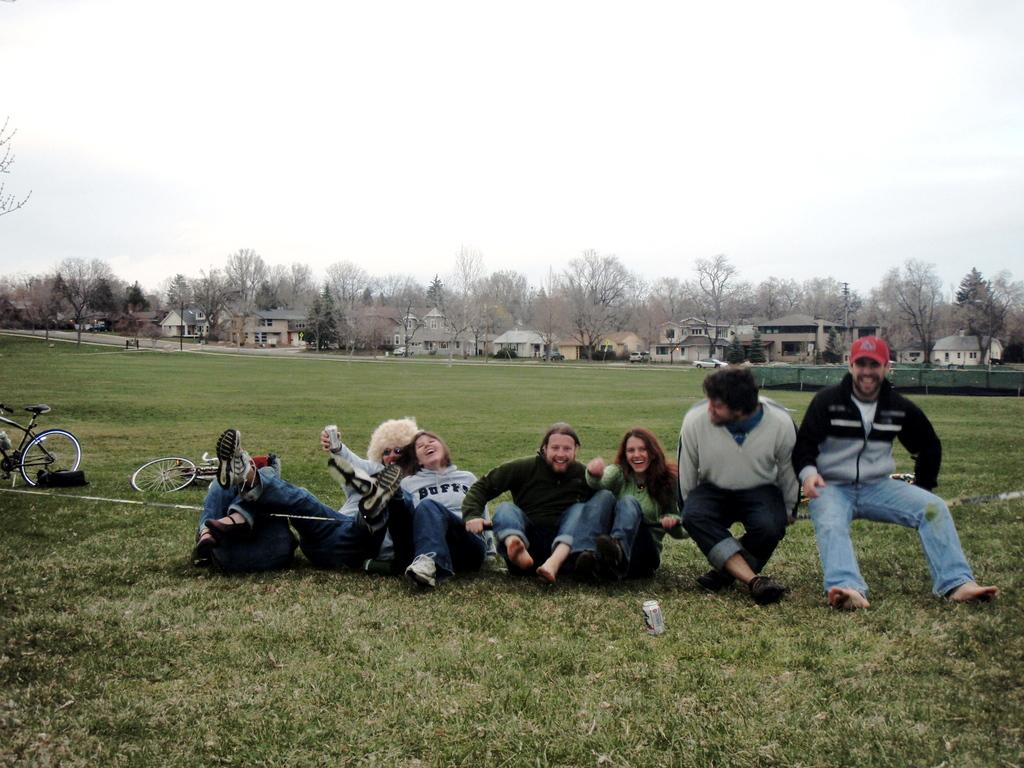What are the people in the image doing? The persons in the image are sitting on a bench and on the ground. What objects can be seen in the image related to transportation? There are bicycles in the image. What type of structures are visible in the image? There are buildings in the image. What type of vegetation is present in the image? Trees are present in the image. What type of pathways are visible in the image? There are roads in the image. What part of the natural environment is visible in the image? The sky is visible in the image. Can you see a monkey marking its territory on the street in the image? There is no monkey or marking of territory on the street in the image. 